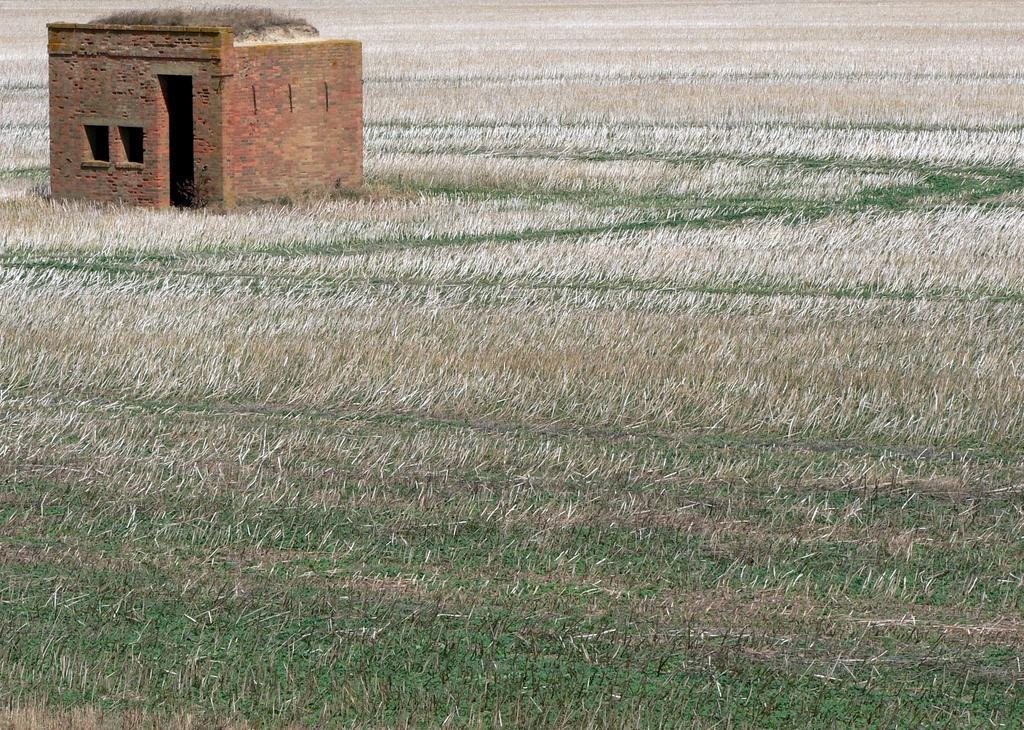What type of house is in the image? There is a small brick house in the image. Where is the house located? The house is on the ground. What is the condition of the ground in the image? There is some mud visible in the image. What type of vegetation is present in the image? There is grass on top of the house and on the ground. What direction does the blade of grass point towards in the image? There is no blade of grass present in the image. What is the source of hope in the image? The image does not depict any source of hope; it only shows a small brick house, mud, and grass. 